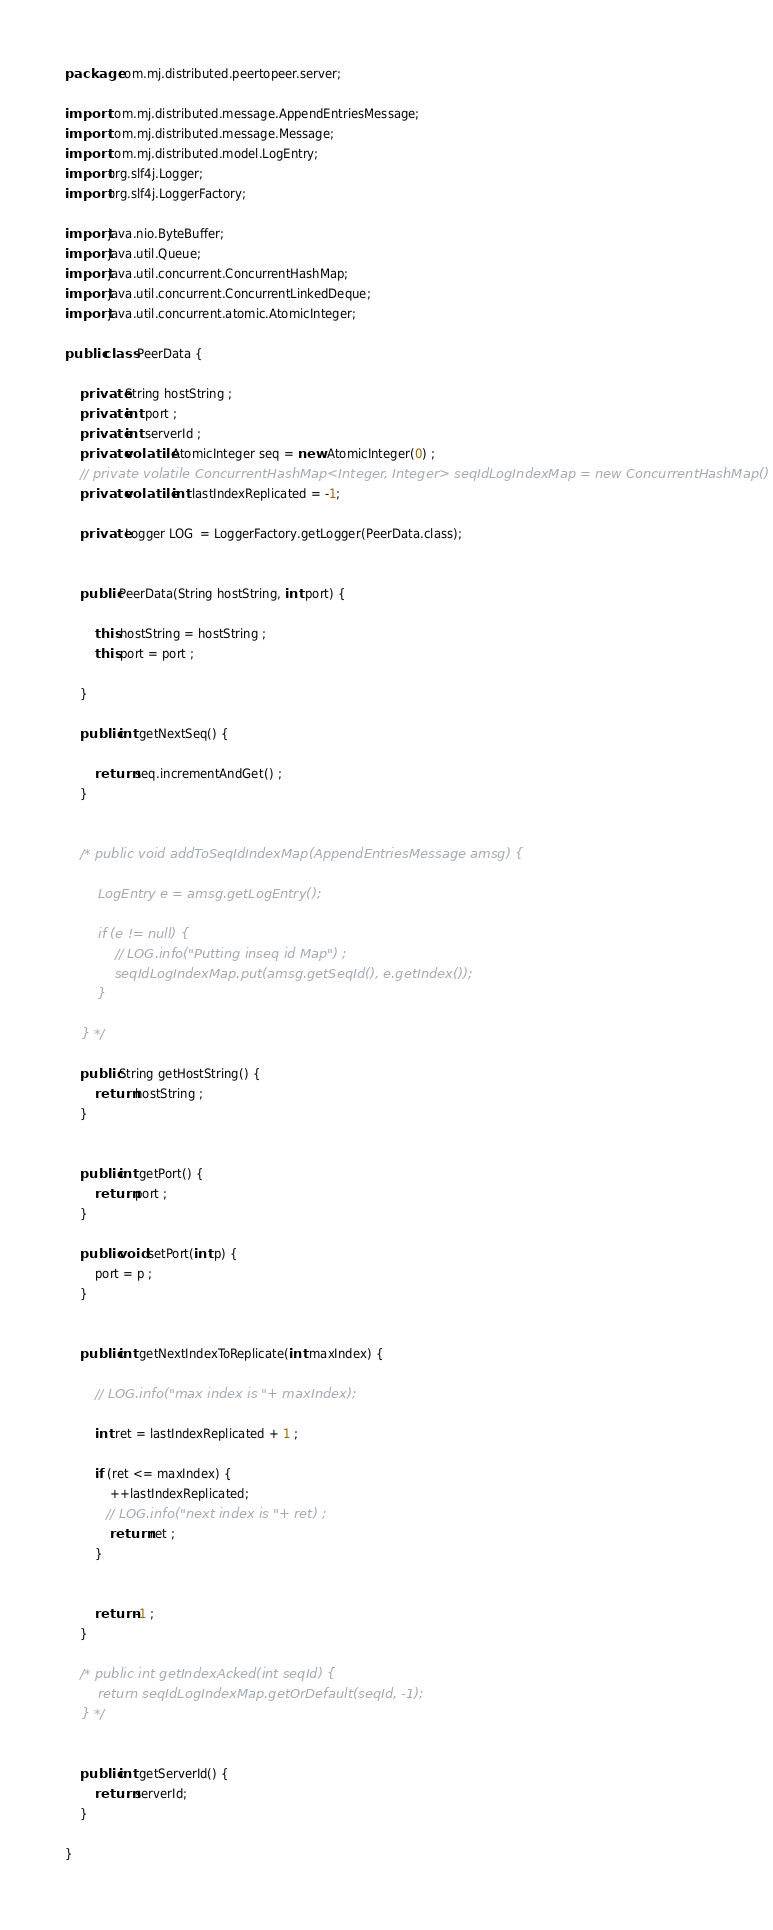<code> <loc_0><loc_0><loc_500><loc_500><_Java_>package com.mj.distributed.peertopeer.server;

import com.mj.distributed.message.AppendEntriesMessage;
import com.mj.distributed.message.Message;
import com.mj.distributed.model.LogEntry;
import org.slf4j.Logger;
import org.slf4j.LoggerFactory;

import java.nio.ByteBuffer;
import java.util.Queue;
import java.util.concurrent.ConcurrentHashMap;
import java.util.concurrent.ConcurrentLinkedDeque;
import java.util.concurrent.atomic.AtomicInteger;

public class PeerData {

    private String hostString ;
    private int port ;
    private int serverId ;
    private volatile AtomicInteger seq = new AtomicInteger(0) ;
    // private volatile ConcurrentHashMap<Integer, Integer> seqIdLogIndexMap = new ConcurrentHashMap() ;
    private volatile int lastIndexReplicated = -1;

    private Logger LOG  = LoggerFactory.getLogger(PeerData.class);


    public PeerData(String hostString, int port) {

        this.hostString = hostString ;
        this.port = port ;

    }

    public int getNextSeq() {

        return seq.incrementAndGet() ;
    }


    /* public void addToSeqIdIndexMap(AppendEntriesMessage amsg) {

        LogEntry e = amsg.getLogEntry();

        if (e != null) {
            // LOG.info("Putting inseq id Map") ;
            seqIdLogIndexMap.put(amsg.getSeqId(), e.getIndex());
        }

    } */

    public String getHostString() {
        return hostString ;
    }


    public int getPort() {
        return port ;
    }

    public void setPort(int p) {
        port = p ;
    }


    public int getNextIndexToReplicate(int maxIndex) {

        // LOG.info("max index is "+ maxIndex);

        int ret = lastIndexReplicated + 1 ;

        if (ret <= maxIndex) {
            ++lastIndexReplicated;
           // LOG.info("next index is "+ ret) ;
            return ret ;
        }


        return -1 ;
    }

    /* public int getIndexAcked(int seqId) {
        return seqIdLogIndexMap.getOrDefault(seqId, -1);
    } */


    public int getServerId() {
        return serverId;
    }

}
</code> 